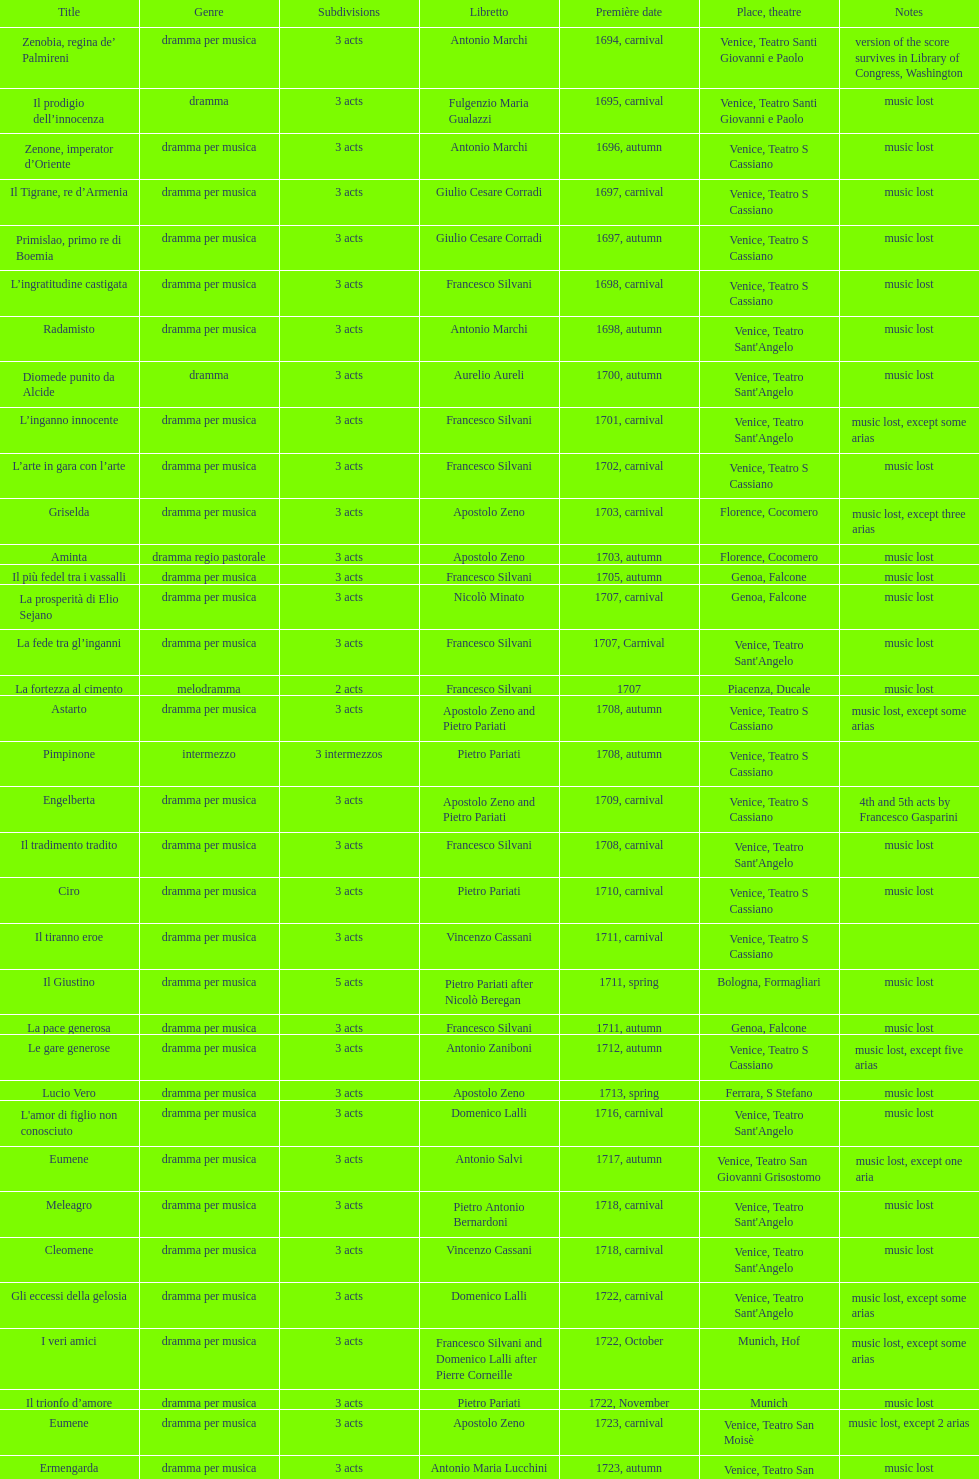In which opera are there the most acts, la fortezza al cimento or astarto? Astarto. 